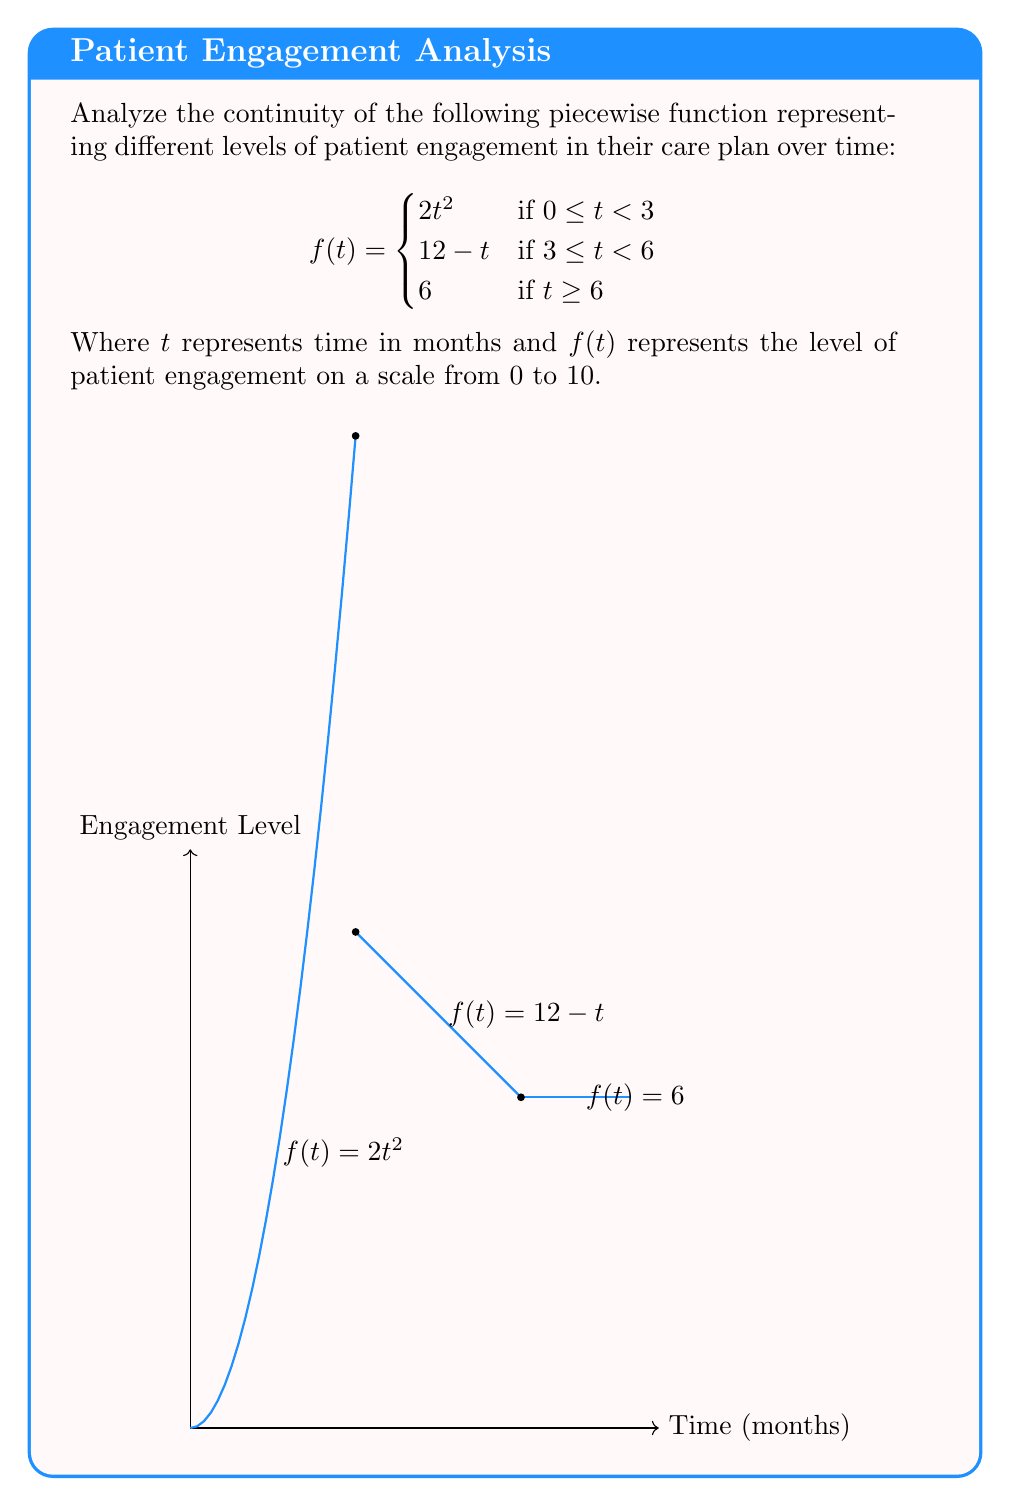Help me with this question. To analyze the continuity of this piecewise function, we need to check for continuity at the points where the function definition changes: $t=3$ and $t=6$.

1. Continuity at $t=3$:
   
   Left-hand limit: $\lim_{t \to 3^-} f(t) = \lim_{t \to 3^-} 2t^2 = 2(3)^2 = 18$
   
   Right-hand limit: $\lim_{t \to 3^+} f(t) = \lim_{t \to 3^+} (12-t) = 12-3 = 9$
   
   Function value: $f(3) = 12-3 = 9$

   Since the left-hand limit ≠ right-hand limit ≠ function value, the function is discontinuous at $t=3$.

2. Continuity at $t=6$:
   
   Left-hand limit: $\lim_{t \to 6^-} f(t) = \lim_{t \to 6^-} (12-t) = 12-6 = 6$
   
   Right-hand limit: $\lim_{t \to 6^+} f(t) = 6$
   
   Function value: $f(6) = 6$

   Since the left-hand limit = right-hand limit = function value, the function is continuous at $t=6$.

3. Continuity elsewhere:
   
   The function is continuous on the intervals $[0,3)$, $(3,6)$, and $(6,\infty)$ as it is defined by continuous functions on these intervals.

Therefore, the function is continuous everywhere except at $t=3$, where it has a jump discontinuity.
Answer: The function is continuous for all $t \geq 0$ except at $t=3$. 